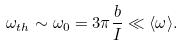Convert formula to latex. <formula><loc_0><loc_0><loc_500><loc_500>\omega _ { t h } \sim \omega _ { 0 } = 3 \pi \frac { b } { I } \ll \langle \omega \rangle .</formula> 